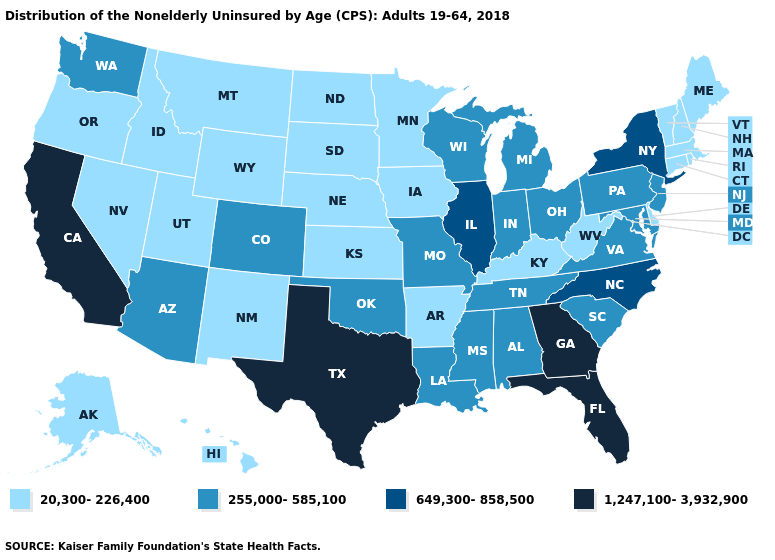Which states hav the highest value in the West?
Keep it brief. California. What is the value of West Virginia?
Write a very short answer. 20,300-226,400. What is the value of North Carolina?
Give a very brief answer. 649,300-858,500. What is the value of Mississippi?
Keep it brief. 255,000-585,100. Name the states that have a value in the range 649,300-858,500?
Write a very short answer. Illinois, New York, North Carolina. What is the highest value in the MidWest ?
Be succinct. 649,300-858,500. Does the map have missing data?
Write a very short answer. No. Which states hav the highest value in the West?
Short answer required. California. What is the lowest value in the Northeast?
Answer briefly. 20,300-226,400. What is the highest value in the South ?
Concise answer only. 1,247,100-3,932,900. Name the states that have a value in the range 20,300-226,400?
Answer briefly. Alaska, Arkansas, Connecticut, Delaware, Hawaii, Idaho, Iowa, Kansas, Kentucky, Maine, Massachusetts, Minnesota, Montana, Nebraska, Nevada, New Hampshire, New Mexico, North Dakota, Oregon, Rhode Island, South Dakota, Utah, Vermont, West Virginia, Wyoming. Does Oregon have a lower value than South Dakota?
Quick response, please. No. Name the states that have a value in the range 1,247,100-3,932,900?
Quick response, please. California, Florida, Georgia, Texas. What is the value of New Jersey?
Give a very brief answer. 255,000-585,100. Name the states that have a value in the range 255,000-585,100?
Keep it brief. Alabama, Arizona, Colorado, Indiana, Louisiana, Maryland, Michigan, Mississippi, Missouri, New Jersey, Ohio, Oklahoma, Pennsylvania, South Carolina, Tennessee, Virginia, Washington, Wisconsin. 